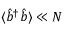<formula> <loc_0><loc_0><loc_500><loc_500>\langle \hat { b } ^ { \dag } \hat { b } \rangle \ll N</formula> 